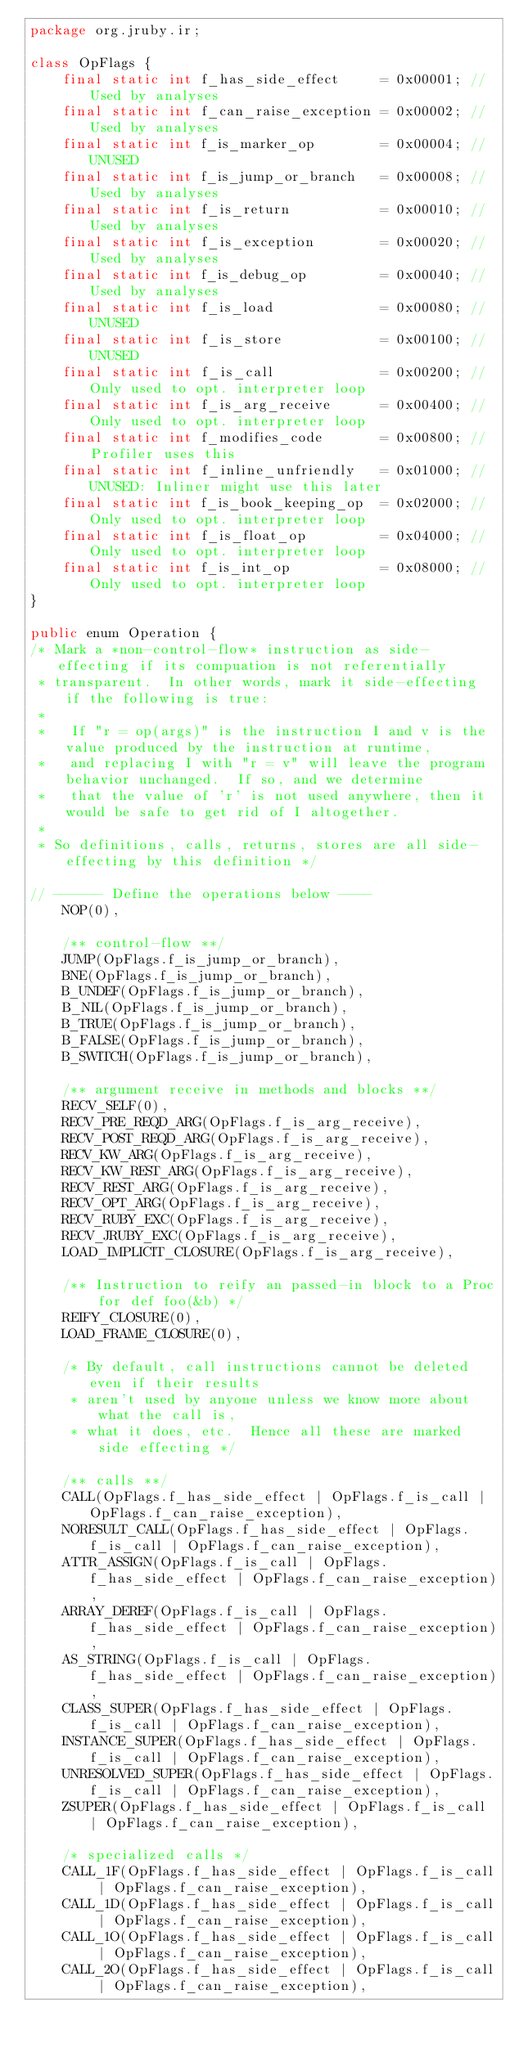Convert code to text. <code><loc_0><loc_0><loc_500><loc_500><_Java_>package org.jruby.ir;

class OpFlags {
    final static int f_has_side_effect     = 0x00001; // Used by analyses
    final static int f_can_raise_exception = 0x00002; // Used by analyses
    final static int f_is_marker_op        = 0x00004; // UNUSED
    final static int f_is_jump_or_branch   = 0x00008; // Used by analyses
    final static int f_is_return           = 0x00010; // Used by analyses
    final static int f_is_exception        = 0x00020; // Used by analyses
    final static int f_is_debug_op         = 0x00040; // Used by analyses
    final static int f_is_load             = 0x00080; // UNUSED
    final static int f_is_store            = 0x00100; // UNUSED
    final static int f_is_call             = 0x00200; // Only used to opt. interpreter loop
    final static int f_is_arg_receive      = 0x00400; // Only used to opt. interpreter loop
    final static int f_modifies_code       = 0x00800; // Profiler uses this
    final static int f_inline_unfriendly   = 0x01000; // UNUSED: Inliner might use this later
    final static int f_is_book_keeping_op  = 0x02000; // Only used to opt. interpreter loop
    final static int f_is_float_op         = 0x04000; // Only used to opt. interpreter loop
    final static int f_is_int_op           = 0x08000; // Only used to opt. interpreter loop
}

public enum Operation {
/* Mark a *non-control-flow* instruction as side-effecting if its compuation is not referentially
 * transparent.  In other words, mark it side-effecting if the following is true:
 *
 *   If "r = op(args)" is the instruction I and v is the value produced by the instruction at runtime,
 *   and replacing I with "r = v" will leave the program behavior unchanged.  If so, and we determine
 *   that the value of 'r' is not used anywhere, then it would be safe to get rid of I altogether.
 *
 * So definitions, calls, returns, stores are all side-effecting by this definition */

// ------ Define the operations below ----
    NOP(0),

    /** control-flow **/
    JUMP(OpFlags.f_is_jump_or_branch),
    BNE(OpFlags.f_is_jump_or_branch),
    B_UNDEF(OpFlags.f_is_jump_or_branch),
    B_NIL(OpFlags.f_is_jump_or_branch),
    B_TRUE(OpFlags.f_is_jump_or_branch),
    B_FALSE(OpFlags.f_is_jump_or_branch),
    B_SWITCH(OpFlags.f_is_jump_or_branch),

    /** argument receive in methods and blocks **/
    RECV_SELF(0),
    RECV_PRE_REQD_ARG(OpFlags.f_is_arg_receive),
    RECV_POST_REQD_ARG(OpFlags.f_is_arg_receive),
    RECV_KW_ARG(OpFlags.f_is_arg_receive),
    RECV_KW_REST_ARG(OpFlags.f_is_arg_receive),
    RECV_REST_ARG(OpFlags.f_is_arg_receive),
    RECV_OPT_ARG(OpFlags.f_is_arg_receive),
    RECV_RUBY_EXC(OpFlags.f_is_arg_receive),
    RECV_JRUBY_EXC(OpFlags.f_is_arg_receive),
    LOAD_IMPLICIT_CLOSURE(OpFlags.f_is_arg_receive),

    /** Instruction to reify an passed-in block to a Proc for def foo(&b) */
    REIFY_CLOSURE(0),
    LOAD_FRAME_CLOSURE(0),

    /* By default, call instructions cannot be deleted even if their results
     * aren't used by anyone unless we know more about what the call is,
     * what it does, etc.  Hence all these are marked side effecting */

    /** calls **/
    CALL(OpFlags.f_has_side_effect | OpFlags.f_is_call | OpFlags.f_can_raise_exception),
    NORESULT_CALL(OpFlags.f_has_side_effect | OpFlags.f_is_call | OpFlags.f_can_raise_exception),
    ATTR_ASSIGN(OpFlags.f_is_call | OpFlags.f_has_side_effect | OpFlags.f_can_raise_exception),
    ARRAY_DEREF(OpFlags.f_is_call | OpFlags.f_has_side_effect | OpFlags.f_can_raise_exception),
    AS_STRING(OpFlags.f_is_call | OpFlags.f_has_side_effect | OpFlags.f_can_raise_exception),
    CLASS_SUPER(OpFlags.f_has_side_effect | OpFlags.f_is_call | OpFlags.f_can_raise_exception),
    INSTANCE_SUPER(OpFlags.f_has_side_effect | OpFlags.f_is_call | OpFlags.f_can_raise_exception),
    UNRESOLVED_SUPER(OpFlags.f_has_side_effect | OpFlags.f_is_call | OpFlags.f_can_raise_exception),
    ZSUPER(OpFlags.f_has_side_effect | OpFlags.f_is_call | OpFlags.f_can_raise_exception),

    /* specialized calls */
    CALL_1F(OpFlags.f_has_side_effect | OpFlags.f_is_call | OpFlags.f_can_raise_exception),
    CALL_1D(OpFlags.f_has_side_effect | OpFlags.f_is_call | OpFlags.f_can_raise_exception),
    CALL_1O(OpFlags.f_has_side_effect | OpFlags.f_is_call | OpFlags.f_can_raise_exception),
    CALL_2O(OpFlags.f_has_side_effect | OpFlags.f_is_call | OpFlags.f_can_raise_exception),</code> 